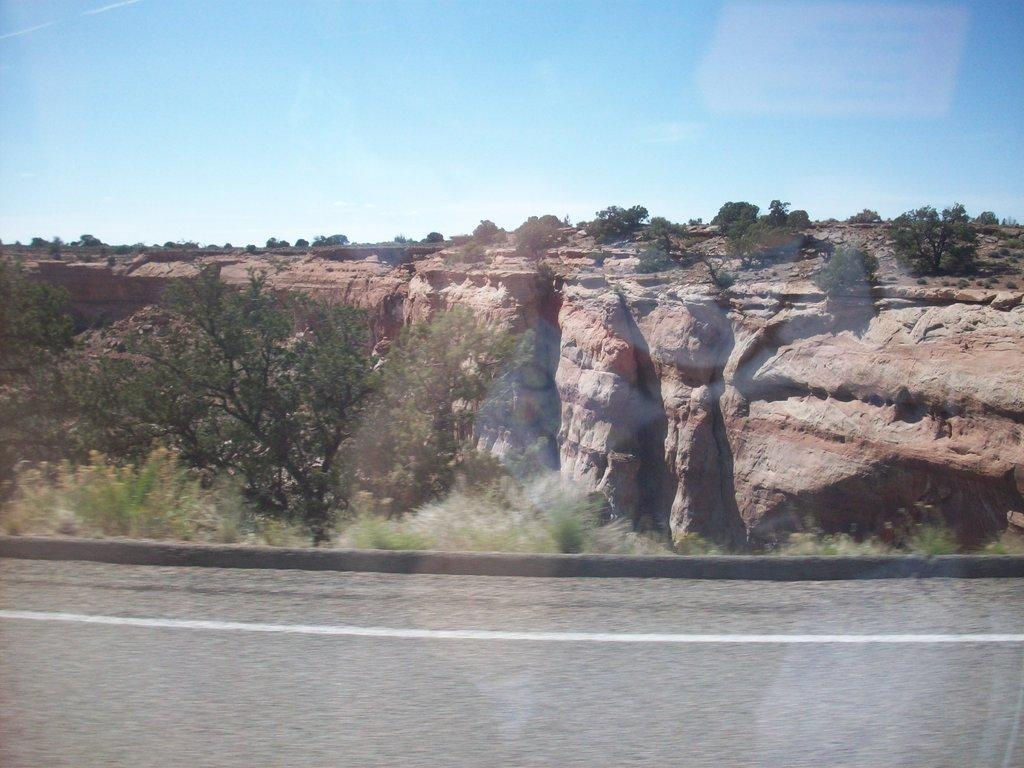What is the main feature of the image? There is a road in the image. What can be seen on the land beside the road? There are plants and trees on the land beside the road. What is located behind the road? There is a hill with trees behind the road. What is visible at the top of the image? The sky is visible at the top of the image. What type of muscle can be seen working on the slope in the image? There is no muscle or person working in the image; it features a road, plants and trees, a hill, and the sky. 